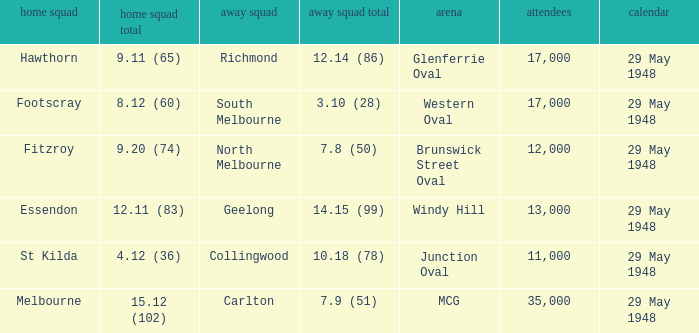In the match where north melbourne was the away team, how much did the home team score? 9.20 (74). Parse the full table. {'header': ['home squad', 'home squad total', 'away squad', 'away squad total', 'arena', 'attendees', 'calendar'], 'rows': [['Hawthorn', '9.11 (65)', 'Richmond', '12.14 (86)', 'Glenferrie Oval', '17,000', '29 May 1948'], ['Footscray', '8.12 (60)', 'South Melbourne', '3.10 (28)', 'Western Oval', '17,000', '29 May 1948'], ['Fitzroy', '9.20 (74)', 'North Melbourne', '7.8 (50)', 'Brunswick Street Oval', '12,000', '29 May 1948'], ['Essendon', '12.11 (83)', 'Geelong', '14.15 (99)', 'Windy Hill', '13,000', '29 May 1948'], ['St Kilda', '4.12 (36)', 'Collingwood', '10.18 (78)', 'Junction Oval', '11,000', '29 May 1948'], ['Melbourne', '15.12 (102)', 'Carlton', '7.9 (51)', 'MCG', '35,000', '29 May 1948']]} 